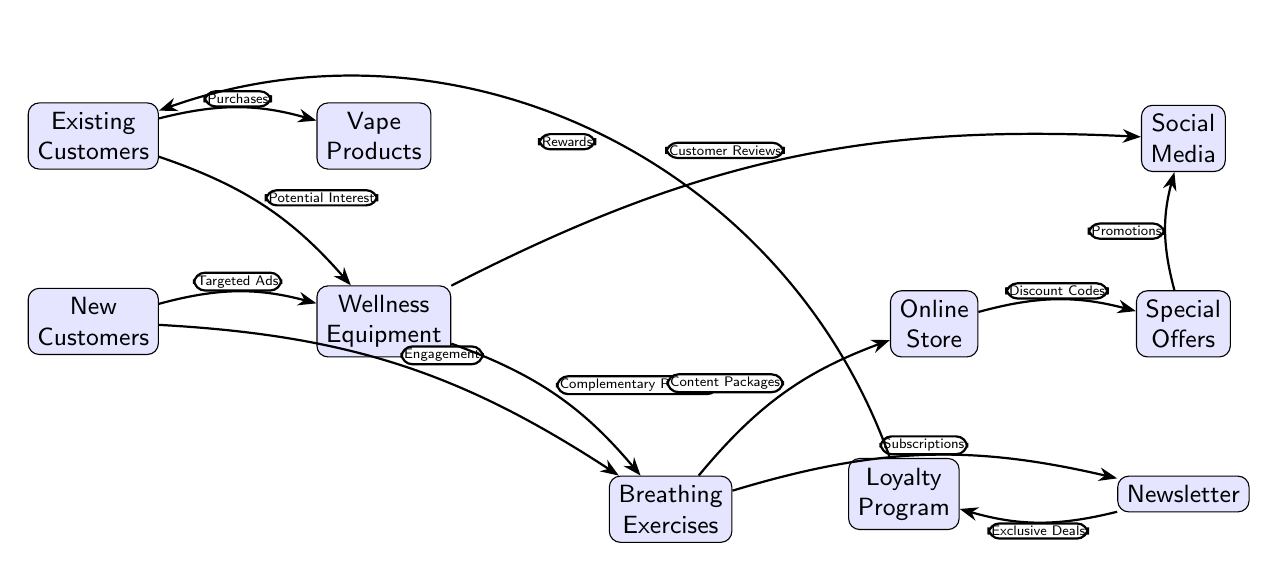What node represents the starting point for existing customers? The starting point for existing customers in the diagram is represented by the "Existing Customers" node, indicating that this is where their journey begins.
Answer: Existing Customers How many nodes are connected to the "wellness equipment" node? The "wellness equipment" node is connected to two nodes: "Existing Customers" (via Potential Interest) and "new customers" (via Targeted Ads), as well as to "breathing exercises" (via Complementary Products), making a total of three connections.
Answer: 3 What type of marketing tactic flows from "new customers" to "breathing exercises"? The connection from "new customers" to "breathing exercises" is labeled "Engagement," indicating this type of marketing tactic is being utilized.
Answer: Engagement What is the role of the "loyalty program" in this diagram? The "loyalty program" node is connected to "newsletter" through "Exclusive Deals" and bends back to "existing customers" with "Rewards," signifying that it serves to retain existing customers through rewards.
Answer: Retain Existing Customers Which node directly affects the "special offers" node? The "online store" node directly influences the "special offers" node with "Discount Codes," indicating a direct relationship that allows customers access to special offers through this avenue.
Answer: Online Store What is the link between "wellness equipment" and "social media"? The "wellness equipment" node connects to "social media" through "Customer Reviews," showing that customer feedback on wellness equipment is being shared on social platforms to attract attention.
Answer: Customer Reviews What flows from "breathing exercises" to "newsletter"? "Subscriptions" flows from the "breathing exercises" node to the "newsletter" node, indicating that subscribing to breathing exercises content would likely connect customers to a newsletter.
Answer: Subscriptions How do special offers connect to social media? "Special offers" connects to "social media" through "Promotions," which indicates that offers are being promoted on social media platforms to drive engagement.
Answer: Promotions What is a potential interest for existing customers aside from vape products? Aside from vape products, the potential interest for existing customers is "wellness equipment," suggesting that there is an opportunity for these customers to be introduced to new product lines.
Answer: Wellness Equipment 